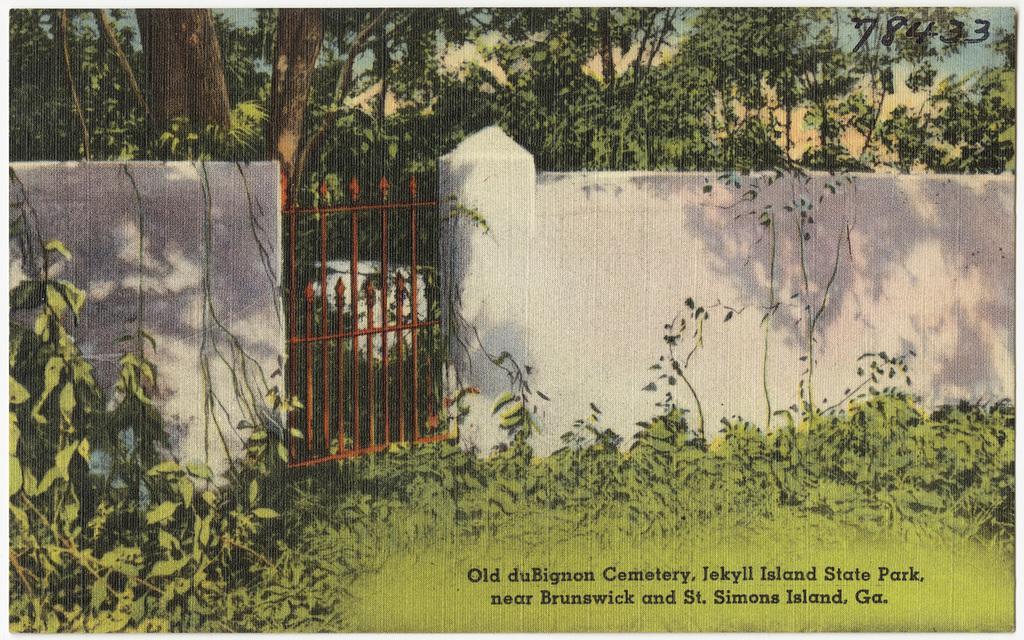In one or two sentences, can you explain what this image depicts? In this image there is a painting, in the painting there is a wall with a metal gate, behind the wall there are trees, in front of the wall there is grass and plants on the surface. 